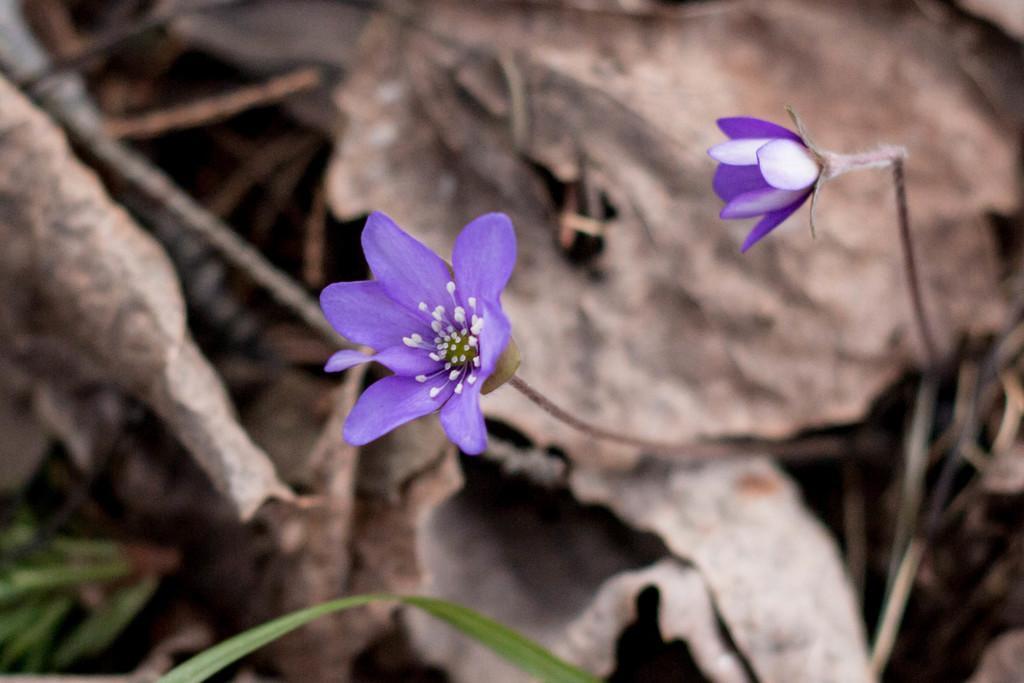Describe this image in one or two sentences. In this image I can see few flowers in white and purple color, grass in green color. In the background I can see few dried leaves and they are in brown color. 